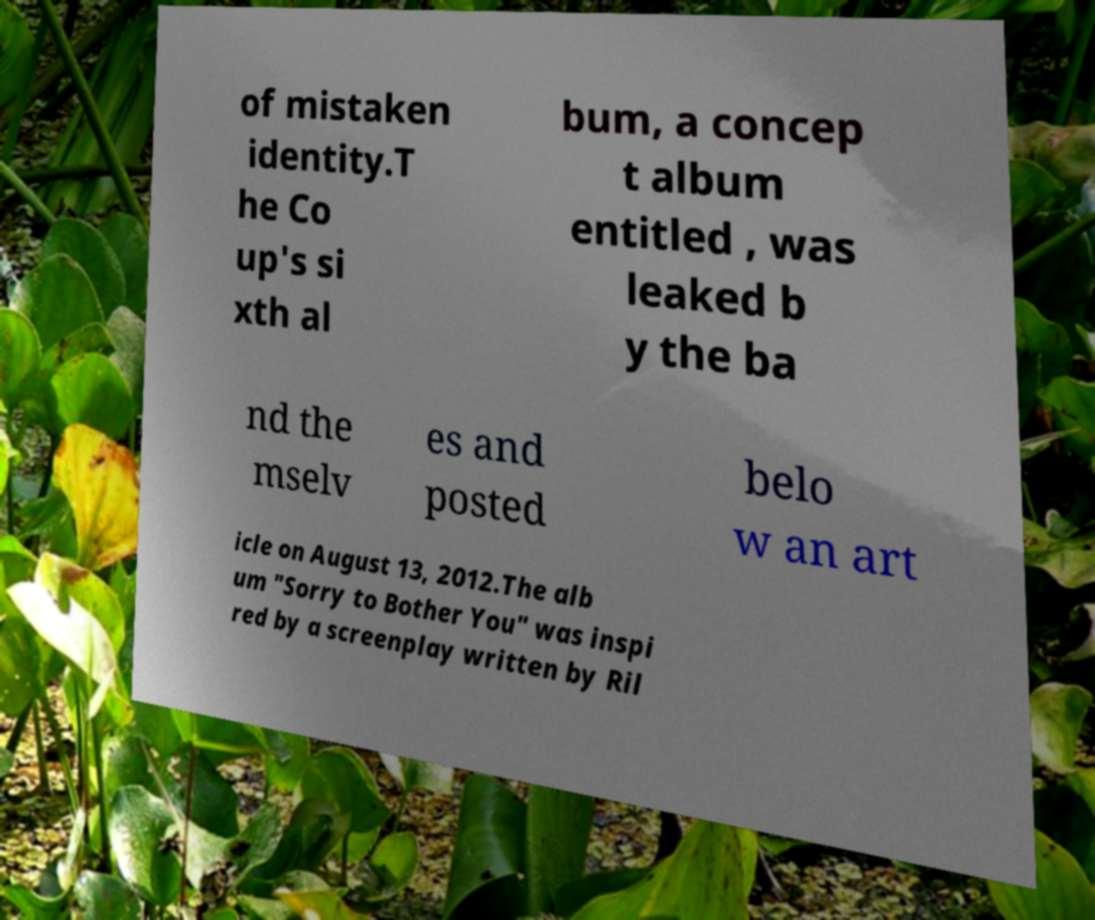There's text embedded in this image that I need extracted. Can you transcribe it verbatim? of mistaken identity.T he Co up's si xth al bum, a concep t album entitled , was leaked b y the ba nd the mselv es and posted belo w an art icle on August 13, 2012.The alb um "Sorry to Bother You" was inspi red by a screenplay written by Ril 